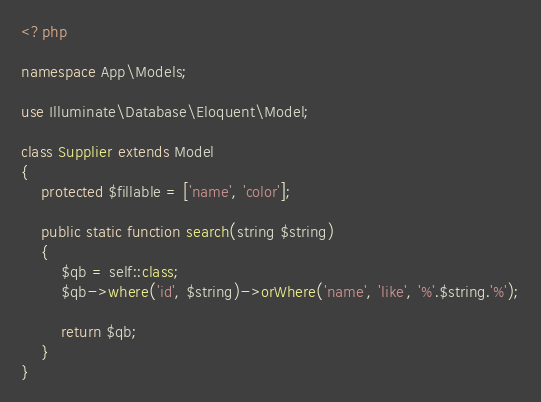<code> <loc_0><loc_0><loc_500><loc_500><_PHP_><?php

namespace App\Models;

use Illuminate\Database\Eloquent\Model;

class Supplier extends Model
{
    protected $fillable = ['name', 'color'];

    public static function search(string $string)
    {
        $qb = self::class;
        $qb->where('id', $string)->orWhere('name', 'like', '%'.$string.'%');

        return $qb;
    }
}
</code> 